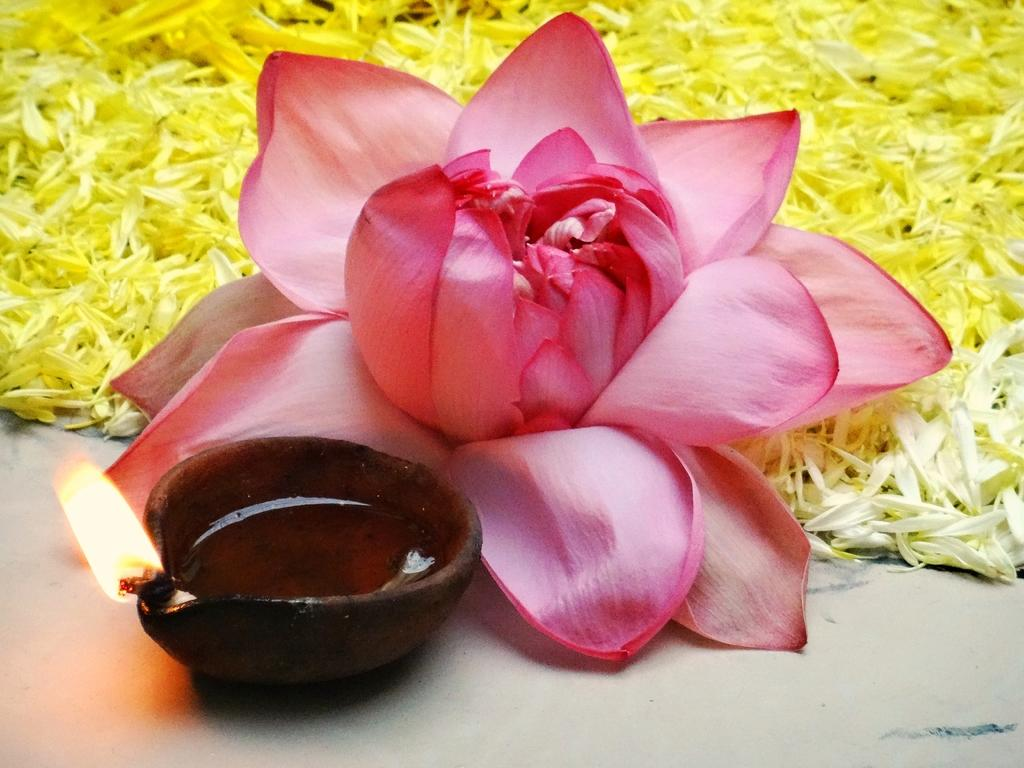What is the main object in the image? There is a diya in the image. What is happening to the diya? There is fire on the diya. What other object can be seen in the image? There is a flower visible in the image. What color is associated with some objects in the image? The color yellow is associated with some objects in the image. How long does it take for the nation to wash the minute details of the image? There is no mention of a nation or washing in the image, and the concept of time is not relevant to the description of the image. 